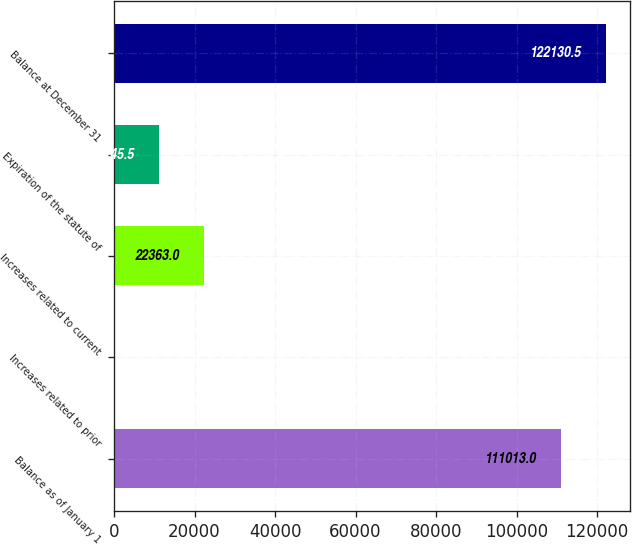<chart> <loc_0><loc_0><loc_500><loc_500><bar_chart><fcel>Balance as of January 1<fcel>Increases related to prior<fcel>Increases related to current<fcel>Expiration of the statute of<fcel>Balance at December 31<nl><fcel>111013<fcel>128<fcel>22363<fcel>11245.5<fcel>122130<nl></chart> 